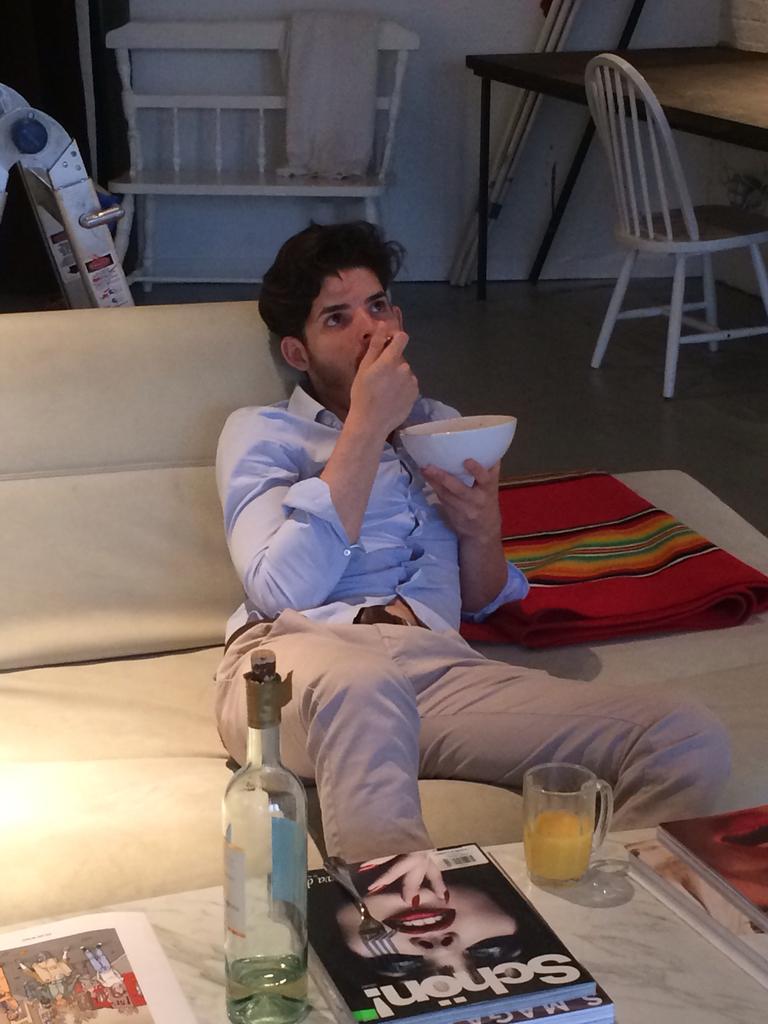How would you summarize this image in a sentence or two? In the center we can see one man sitting on the couch and he is holding bowl and spoon. In front there is a table,on table we can see book,fork,wine bottle,glass and paper. In the background there is a bench,table,chair, pipe,wall and blanket. 